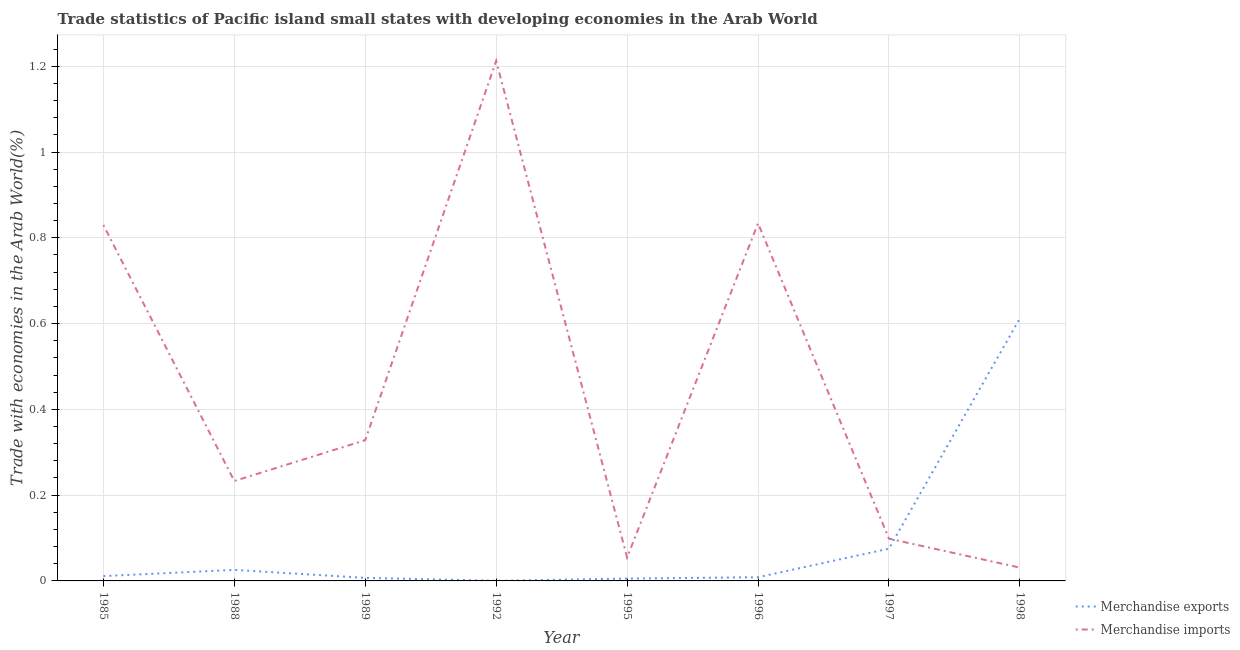What is the merchandise imports in 1992?
Keep it short and to the point. 1.21. Across all years, what is the maximum merchandise imports?
Make the answer very short. 1.21. Across all years, what is the minimum merchandise imports?
Your answer should be compact. 0.03. In which year was the merchandise imports minimum?
Provide a short and direct response. 1998. What is the total merchandise imports in the graph?
Provide a short and direct response. 3.62. What is the difference between the merchandise exports in 1989 and that in 1998?
Your response must be concise. -0.61. What is the difference between the merchandise exports in 1992 and the merchandise imports in 1995?
Offer a terse response. -0.05. What is the average merchandise exports per year?
Make the answer very short. 0.09. In the year 1995, what is the difference between the merchandise imports and merchandise exports?
Make the answer very short. 0.05. What is the ratio of the merchandise exports in 1995 to that in 1997?
Provide a short and direct response. 0.07. Is the difference between the merchandise imports in 1985 and 1996 greater than the difference between the merchandise exports in 1985 and 1996?
Your response must be concise. No. What is the difference between the highest and the second highest merchandise imports?
Your response must be concise. 0.38. What is the difference between the highest and the lowest merchandise exports?
Your answer should be compact. 0.61. Is the sum of the merchandise exports in 1985 and 1992 greater than the maximum merchandise imports across all years?
Keep it short and to the point. No. How many lines are there?
Your answer should be compact. 2. How many years are there in the graph?
Give a very brief answer. 8. Does the graph contain grids?
Provide a short and direct response. Yes. What is the title of the graph?
Your answer should be very brief. Trade statistics of Pacific island small states with developing economies in the Arab World. Does "All education staff compensation" appear as one of the legend labels in the graph?
Give a very brief answer. No. What is the label or title of the Y-axis?
Offer a terse response. Trade with economies in the Arab World(%). What is the Trade with economies in the Arab World(%) in Merchandise exports in 1985?
Keep it short and to the point. 0.01. What is the Trade with economies in the Arab World(%) of Merchandise imports in 1985?
Make the answer very short. 0.83. What is the Trade with economies in the Arab World(%) in Merchandise exports in 1988?
Make the answer very short. 0.03. What is the Trade with economies in the Arab World(%) of Merchandise imports in 1988?
Keep it short and to the point. 0.23. What is the Trade with economies in the Arab World(%) in Merchandise exports in 1989?
Keep it short and to the point. 0.01. What is the Trade with economies in the Arab World(%) in Merchandise imports in 1989?
Your answer should be compact. 0.33. What is the Trade with economies in the Arab World(%) in Merchandise exports in 1992?
Your response must be concise. 0. What is the Trade with economies in the Arab World(%) in Merchandise imports in 1992?
Your response must be concise. 1.21. What is the Trade with economies in the Arab World(%) of Merchandise exports in 1995?
Give a very brief answer. 0.01. What is the Trade with economies in the Arab World(%) in Merchandise imports in 1995?
Ensure brevity in your answer.  0.05. What is the Trade with economies in the Arab World(%) of Merchandise exports in 1996?
Your response must be concise. 0.01. What is the Trade with economies in the Arab World(%) in Merchandise imports in 1996?
Your answer should be compact. 0.83. What is the Trade with economies in the Arab World(%) of Merchandise exports in 1997?
Provide a succinct answer. 0.08. What is the Trade with economies in the Arab World(%) in Merchandise imports in 1997?
Ensure brevity in your answer.  0.1. What is the Trade with economies in the Arab World(%) of Merchandise exports in 1998?
Offer a terse response. 0.61. What is the Trade with economies in the Arab World(%) in Merchandise imports in 1998?
Offer a terse response. 0.03. Across all years, what is the maximum Trade with economies in the Arab World(%) in Merchandise exports?
Make the answer very short. 0.61. Across all years, what is the maximum Trade with economies in the Arab World(%) of Merchandise imports?
Make the answer very short. 1.21. Across all years, what is the minimum Trade with economies in the Arab World(%) in Merchandise exports?
Give a very brief answer. 0. Across all years, what is the minimum Trade with economies in the Arab World(%) of Merchandise imports?
Provide a succinct answer. 0.03. What is the total Trade with economies in the Arab World(%) in Merchandise exports in the graph?
Give a very brief answer. 0.75. What is the total Trade with economies in the Arab World(%) in Merchandise imports in the graph?
Keep it short and to the point. 3.62. What is the difference between the Trade with economies in the Arab World(%) in Merchandise exports in 1985 and that in 1988?
Provide a short and direct response. -0.01. What is the difference between the Trade with economies in the Arab World(%) of Merchandise imports in 1985 and that in 1988?
Provide a succinct answer. 0.6. What is the difference between the Trade with economies in the Arab World(%) in Merchandise exports in 1985 and that in 1989?
Provide a short and direct response. 0. What is the difference between the Trade with economies in the Arab World(%) in Merchandise imports in 1985 and that in 1989?
Your response must be concise. 0.5. What is the difference between the Trade with economies in the Arab World(%) in Merchandise exports in 1985 and that in 1992?
Your answer should be very brief. 0.01. What is the difference between the Trade with economies in the Arab World(%) of Merchandise imports in 1985 and that in 1992?
Keep it short and to the point. -0.38. What is the difference between the Trade with economies in the Arab World(%) in Merchandise exports in 1985 and that in 1995?
Your answer should be compact. 0.01. What is the difference between the Trade with economies in the Arab World(%) of Merchandise imports in 1985 and that in 1995?
Ensure brevity in your answer.  0.78. What is the difference between the Trade with economies in the Arab World(%) of Merchandise exports in 1985 and that in 1996?
Keep it short and to the point. 0. What is the difference between the Trade with economies in the Arab World(%) of Merchandise imports in 1985 and that in 1996?
Your response must be concise. -0. What is the difference between the Trade with economies in the Arab World(%) in Merchandise exports in 1985 and that in 1997?
Offer a very short reply. -0.06. What is the difference between the Trade with economies in the Arab World(%) in Merchandise imports in 1985 and that in 1997?
Ensure brevity in your answer.  0.73. What is the difference between the Trade with economies in the Arab World(%) of Merchandise exports in 1985 and that in 1998?
Offer a very short reply. -0.6. What is the difference between the Trade with economies in the Arab World(%) of Merchandise imports in 1985 and that in 1998?
Offer a very short reply. 0.8. What is the difference between the Trade with economies in the Arab World(%) in Merchandise exports in 1988 and that in 1989?
Ensure brevity in your answer.  0.02. What is the difference between the Trade with economies in the Arab World(%) in Merchandise imports in 1988 and that in 1989?
Provide a succinct answer. -0.1. What is the difference between the Trade with economies in the Arab World(%) of Merchandise exports in 1988 and that in 1992?
Your answer should be very brief. 0.03. What is the difference between the Trade with economies in the Arab World(%) of Merchandise imports in 1988 and that in 1992?
Your answer should be compact. -0.98. What is the difference between the Trade with economies in the Arab World(%) of Merchandise exports in 1988 and that in 1995?
Make the answer very short. 0.02. What is the difference between the Trade with economies in the Arab World(%) in Merchandise imports in 1988 and that in 1995?
Give a very brief answer. 0.18. What is the difference between the Trade with economies in the Arab World(%) in Merchandise exports in 1988 and that in 1996?
Your answer should be compact. 0.02. What is the difference between the Trade with economies in the Arab World(%) in Merchandise imports in 1988 and that in 1996?
Provide a short and direct response. -0.6. What is the difference between the Trade with economies in the Arab World(%) in Merchandise exports in 1988 and that in 1997?
Give a very brief answer. -0.05. What is the difference between the Trade with economies in the Arab World(%) in Merchandise imports in 1988 and that in 1997?
Provide a short and direct response. 0.13. What is the difference between the Trade with economies in the Arab World(%) of Merchandise exports in 1988 and that in 1998?
Your answer should be very brief. -0.59. What is the difference between the Trade with economies in the Arab World(%) in Merchandise imports in 1988 and that in 1998?
Give a very brief answer. 0.2. What is the difference between the Trade with economies in the Arab World(%) in Merchandise exports in 1989 and that in 1992?
Offer a very short reply. 0.01. What is the difference between the Trade with economies in the Arab World(%) of Merchandise imports in 1989 and that in 1992?
Give a very brief answer. -0.88. What is the difference between the Trade with economies in the Arab World(%) in Merchandise exports in 1989 and that in 1995?
Make the answer very short. 0. What is the difference between the Trade with economies in the Arab World(%) in Merchandise imports in 1989 and that in 1995?
Make the answer very short. 0.27. What is the difference between the Trade with economies in the Arab World(%) in Merchandise exports in 1989 and that in 1996?
Your answer should be compact. -0. What is the difference between the Trade with economies in the Arab World(%) in Merchandise imports in 1989 and that in 1996?
Provide a short and direct response. -0.51. What is the difference between the Trade with economies in the Arab World(%) of Merchandise exports in 1989 and that in 1997?
Provide a succinct answer. -0.07. What is the difference between the Trade with economies in the Arab World(%) of Merchandise imports in 1989 and that in 1997?
Provide a succinct answer. 0.23. What is the difference between the Trade with economies in the Arab World(%) of Merchandise exports in 1989 and that in 1998?
Offer a terse response. -0.61. What is the difference between the Trade with economies in the Arab World(%) in Merchandise imports in 1989 and that in 1998?
Your answer should be very brief. 0.3. What is the difference between the Trade with economies in the Arab World(%) of Merchandise exports in 1992 and that in 1995?
Your response must be concise. -0.01. What is the difference between the Trade with economies in the Arab World(%) in Merchandise imports in 1992 and that in 1995?
Keep it short and to the point. 1.16. What is the difference between the Trade with economies in the Arab World(%) of Merchandise exports in 1992 and that in 1996?
Ensure brevity in your answer.  -0.01. What is the difference between the Trade with economies in the Arab World(%) of Merchandise imports in 1992 and that in 1996?
Give a very brief answer. 0.38. What is the difference between the Trade with economies in the Arab World(%) of Merchandise exports in 1992 and that in 1997?
Provide a short and direct response. -0.07. What is the difference between the Trade with economies in the Arab World(%) of Merchandise imports in 1992 and that in 1997?
Make the answer very short. 1.11. What is the difference between the Trade with economies in the Arab World(%) in Merchandise exports in 1992 and that in 1998?
Make the answer very short. -0.61. What is the difference between the Trade with economies in the Arab World(%) in Merchandise imports in 1992 and that in 1998?
Provide a succinct answer. 1.18. What is the difference between the Trade with economies in the Arab World(%) of Merchandise exports in 1995 and that in 1996?
Your answer should be very brief. -0. What is the difference between the Trade with economies in the Arab World(%) in Merchandise imports in 1995 and that in 1996?
Offer a very short reply. -0.78. What is the difference between the Trade with economies in the Arab World(%) in Merchandise exports in 1995 and that in 1997?
Provide a short and direct response. -0.07. What is the difference between the Trade with economies in the Arab World(%) in Merchandise imports in 1995 and that in 1997?
Provide a succinct answer. -0.04. What is the difference between the Trade with economies in the Arab World(%) in Merchandise exports in 1995 and that in 1998?
Provide a short and direct response. -0.61. What is the difference between the Trade with economies in the Arab World(%) of Merchandise imports in 1995 and that in 1998?
Provide a succinct answer. 0.02. What is the difference between the Trade with economies in the Arab World(%) in Merchandise exports in 1996 and that in 1997?
Provide a short and direct response. -0.07. What is the difference between the Trade with economies in the Arab World(%) of Merchandise imports in 1996 and that in 1997?
Your answer should be compact. 0.74. What is the difference between the Trade with economies in the Arab World(%) of Merchandise exports in 1996 and that in 1998?
Give a very brief answer. -0.6. What is the difference between the Trade with economies in the Arab World(%) of Merchandise imports in 1996 and that in 1998?
Offer a terse response. 0.8. What is the difference between the Trade with economies in the Arab World(%) in Merchandise exports in 1997 and that in 1998?
Make the answer very short. -0.54. What is the difference between the Trade with economies in the Arab World(%) of Merchandise imports in 1997 and that in 1998?
Ensure brevity in your answer.  0.07. What is the difference between the Trade with economies in the Arab World(%) of Merchandise exports in 1985 and the Trade with economies in the Arab World(%) of Merchandise imports in 1988?
Your answer should be very brief. -0.22. What is the difference between the Trade with economies in the Arab World(%) of Merchandise exports in 1985 and the Trade with economies in the Arab World(%) of Merchandise imports in 1989?
Your answer should be very brief. -0.32. What is the difference between the Trade with economies in the Arab World(%) in Merchandise exports in 1985 and the Trade with economies in the Arab World(%) in Merchandise imports in 1992?
Offer a very short reply. -1.2. What is the difference between the Trade with economies in the Arab World(%) of Merchandise exports in 1985 and the Trade with economies in the Arab World(%) of Merchandise imports in 1995?
Make the answer very short. -0.04. What is the difference between the Trade with economies in the Arab World(%) of Merchandise exports in 1985 and the Trade with economies in the Arab World(%) of Merchandise imports in 1996?
Make the answer very short. -0.82. What is the difference between the Trade with economies in the Arab World(%) of Merchandise exports in 1985 and the Trade with economies in the Arab World(%) of Merchandise imports in 1997?
Give a very brief answer. -0.09. What is the difference between the Trade with economies in the Arab World(%) in Merchandise exports in 1985 and the Trade with economies in the Arab World(%) in Merchandise imports in 1998?
Make the answer very short. -0.02. What is the difference between the Trade with economies in the Arab World(%) in Merchandise exports in 1988 and the Trade with economies in the Arab World(%) in Merchandise imports in 1989?
Give a very brief answer. -0.3. What is the difference between the Trade with economies in the Arab World(%) of Merchandise exports in 1988 and the Trade with economies in the Arab World(%) of Merchandise imports in 1992?
Provide a succinct answer. -1.19. What is the difference between the Trade with economies in the Arab World(%) of Merchandise exports in 1988 and the Trade with economies in the Arab World(%) of Merchandise imports in 1995?
Keep it short and to the point. -0.03. What is the difference between the Trade with economies in the Arab World(%) in Merchandise exports in 1988 and the Trade with economies in the Arab World(%) in Merchandise imports in 1996?
Your answer should be very brief. -0.81. What is the difference between the Trade with economies in the Arab World(%) in Merchandise exports in 1988 and the Trade with economies in the Arab World(%) in Merchandise imports in 1997?
Offer a terse response. -0.07. What is the difference between the Trade with economies in the Arab World(%) of Merchandise exports in 1988 and the Trade with economies in the Arab World(%) of Merchandise imports in 1998?
Offer a terse response. -0.01. What is the difference between the Trade with economies in the Arab World(%) of Merchandise exports in 1989 and the Trade with economies in the Arab World(%) of Merchandise imports in 1992?
Give a very brief answer. -1.21. What is the difference between the Trade with economies in the Arab World(%) of Merchandise exports in 1989 and the Trade with economies in the Arab World(%) of Merchandise imports in 1995?
Provide a succinct answer. -0.05. What is the difference between the Trade with economies in the Arab World(%) in Merchandise exports in 1989 and the Trade with economies in the Arab World(%) in Merchandise imports in 1996?
Your answer should be very brief. -0.83. What is the difference between the Trade with economies in the Arab World(%) in Merchandise exports in 1989 and the Trade with economies in the Arab World(%) in Merchandise imports in 1997?
Provide a succinct answer. -0.09. What is the difference between the Trade with economies in the Arab World(%) in Merchandise exports in 1989 and the Trade with economies in the Arab World(%) in Merchandise imports in 1998?
Ensure brevity in your answer.  -0.02. What is the difference between the Trade with economies in the Arab World(%) of Merchandise exports in 1992 and the Trade with economies in the Arab World(%) of Merchandise imports in 1995?
Provide a short and direct response. -0.05. What is the difference between the Trade with economies in the Arab World(%) in Merchandise exports in 1992 and the Trade with economies in the Arab World(%) in Merchandise imports in 1996?
Provide a short and direct response. -0.83. What is the difference between the Trade with economies in the Arab World(%) of Merchandise exports in 1992 and the Trade with economies in the Arab World(%) of Merchandise imports in 1997?
Your answer should be compact. -0.1. What is the difference between the Trade with economies in the Arab World(%) of Merchandise exports in 1992 and the Trade with economies in the Arab World(%) of Merchandise imports in 1998?
Ensure brevity in your answer.  -0.03. What is the difference between the Trade with economies in the Arab World(%) in Merchandise exports in 1995 and the Trade with economies in the Arab World(%) in Merchandise imports in 1996?
Keep it short and to the point. -0.83. What is the difference between the Trade with economies in the Arab World(%) of Merchandise exports in 1995 and the Trade with economies in the Arab World(%) of Merchandise imports in 1997?
Your answer should be compact. -0.09. What is the difference between the Trade with economies in the Arab World(%) of Merchandise exports in 1995 and the Trade with economies in the Arab World(%) of Merchandise imports in 1998?
Give a very brief answer. -0.03. What is the difference between the Trade with economies in the Arab World(%) in Merchandise exports in 1996 and the Trade with economies in the Arab World(%) in Merchandise imports in 1997?
Your answer should be compact. -0.09. What is the difference between the Trade with economies in the Arab World(%) of Merchandise exports in 1996 and the Trade with economies in the Arab World(%) of Merchandise imports in 1998?
Ensure brevity in your answer.  -0.02. What is the difference between the Trade with economies in the Arab World(%) of Merchandise exports in 1997 and the Trade with economies in the Arab World(%) of Merchandise imports in 1998?
Offer a terse response. 0.04. What is the average Trade with economies in the Arab World(%) of Merchandise exports per year?
Give a very brief answer. 0.09. What is the average Trade with economies in the Arab World(%) of Merchandise imports per year?
Ensure brevity in your answer.  0.45. In the year 1985, what is the difference between the Trade with economies in the Arab World(%) in Merchandise exports and Trade with economies in the Arab World(%) in Merchandise imports?
Your answer should be very brief. -0.82. In the year 1988, what is the difference between the Trade with economies in the Arab World(%) in Merchandise exports and Trade with economies in the Arab World(%) in Merchandise imports?
Give a very brief answer. -0.21. In the year 1989, what is the difference between the Trade with economies in the Arab World(%) in Merchandise exports and Trade with economies in the Arab World(%) in Merchandise imports?
Your response must be concise. -0.32. In the year 1992, what is the difference between the Trade with economies in the Arab World(%) of Merchandise exports and Trade with economies in the Arab World(%) of Merchandise imports?
Your answer should be compact. -1.21. In the year 1995, what is the difference between the Trade with economies in the Arab World(%) in Merchandise exports and Trade with economies in the Arab World(%) in Merchandise imports?
Ensure brevity in your answer.  -0.05. In the year 1996, what is the difference between the Trade with economies in the Arab World(%) in Merchandise exports and Trade with economies in the Arab World(%) in Merchandise imports?
Give a very brief answer. -0.83. In the year 1997, what is the difference between the Trade with economies in the Arab World(%) of Merchandise exports and Trade with economies in the Arab World(%) of Merchandise imports?
Make the answer very short. -0.02. In the year 1998, what is the difference between the Trade with economies in the Arab World(%) in Merchandise exports and Trade with economies in the Arab World(%) in Merchandise imports?
Keep it short and to the point. 0.58. What is the ratio of the Trade with economies in the Arab World(%) in Merchandise exports in 1985 to that in 1988?
Your answer should be compact. 0.44. What is the ratio of the Trade with economies in the Arab World(%) of Merchandise imports in 1985 to that in 1988?
Your answer should be very brief. 3.56. What is the ratio of the Trade with economies in the Arab World(%) of Merchandise exports in 1985 to that in 1989?
Offer a very short reply. 1.57. What is the ratio of the Trade with economies in the Arab World(%) of Merchandise imports in 1985 to that in 1989?
Ensure brevity in your answer.  2.53. What is the ratio of the Trade with economies in the Arab World(%) of Merchandise exports in 1985 to that in 1992?
Give a very brief answer. 34.52. What is the ratio of the Trade with economies in the Arab World(%) in Merchandise imports in 1985 to that in 1992?
Your answer should be very brief. 0.68. What is the ratio of the Trade with economies in the Arab World(%) in Merchandise exports in 1985 to that in 1995?
Make the answer very short. 2.06. What is the ratio of the Trade with economies in the Arab World(%) in Merchandise imports in 1985 to that in 1995?
Your answer should be compact. 15.21. What is the ratio of the Trade with economies in the Arab World(%) in Merchandise exports in 1985 to that in 1996?
Give a very brief answer. 1.3. What is the ratio of the Trade with economies in the Arab World(%) in Merchandise imports in 1985 to that in 1996?
Your answer should be very brief. 1. What is the ratio of the Trade with economies in the Arab World(%) in Merchandise exports in 1985 to that in 1997?
Keep it short and to the point. 0.15. What is the ratio of the Trade with economies in the Arab World(%) in Merchandise imports in 1985 to that in 1997?
Provide a short and direct response. 8.42. What is the ratio of the Trade with economies in the Arab World(%) in Merchandise exports in 1985 to that in 1998?
Give a very brief answer. 0.02. What is the ratio of the Trade with economies in the Arab World(%) in Merchandise imports in 1985 to that in 1998?
Make the answer very short. 26.81. What is the ratio of the Trade with economies in the Arab World(%) of Merchandise exports in 1988 to that in 1989?
Offer a very short reply. 3.6. What is the ratio of the Trade with economies in the Arab World(%) in Merchandise imports in 1988 to that in 1989?
Offer a terse response. 0.71. What is the ratio of the Trade with economies in the Arab World(%) in Merchandise exports in 1988 to that in 1992?
Provide a succinct answer. 79.11. What is the ratio of the Trade with economies in the Arab World(%) in Merchandise imports in 1988 to that in 1992?
Provide a short and direct response. 0.19. What is the ratio of the Trade with economies in the Arab World(%) in Merchandise exports in 1988 to that in 1995?
Provide a short and direct response. 4.73. What is the ratio of the Trade with economies in the Arab World(%) in Merchandise imports in 1988 to that in 1995?
Provide a succinct answer. 4.27. What is the ratio of the Trade with economies in the Arab World(%) of Merchandise exports in 1988 to that in 1996?
Your answer should be compact. 2.98. What is the ratio of the Trade with economies in the Arab World(%) of Merchandise imports in 1988 to that in 1996?
Provide a short and direct response. 0.28. What is the ratio of the Trade with economies in the Arab World(%) of Merchandise exports in 1988 to that in 1997?
Provide a succinct answer. 0.34. What is the ratio of the Trade with economies in the Arab World(%) of Merchandise imports in 1988 to that in 1997?
Your answer should be very brief. 2.37. What is the ratio of the Trade with economies in the Arab World(%) in Merchandise exports in 1988 to that in 1998?
Your response must be concise. 0.04. What is the ratio of the Trade with economies in the Arab World(%) of Merchandise imports in 1988 to that in 1998?
Make the answer very short. 7.53. What is the ratio of the Trade with economies in the Arab World(%) in Merchandise exports in 1989 to that in 1992?
Ensure brevity in your answer.  22. What is the ratio of the Trade with economies in the Arab World(%) of Merchandise imports in 1989 to that in 1992?
Provide a succinct answer. 0.27. What is the ratio of the Trade with economies in the Arab World(%) of Merchandise exports in 1989 to that in 1995?
Your answer should be very brief. 1.32. What is the ratio of the Trade with economies in the Arab World(%) in Merchandise imports in 1989 to that in 1995?
Your answer should be very brief. 6.02. What is the ratio of the Trade with economies in the Arab World(%) of Merchandise exports in 1989 to that in 1996?
Make the answer very short. 0.83. What is the ratio of the Trade with economies in the Arab World(%) of Merchandise imports in 1989 to that in 1996?
Your answer should be very brief. 0.39. What is the ratio of the Trade with economies in the Arab World(%) of Merchandise exports in 1989 to that in 1997?
Provide a succinct answer. 0.1. What is the ratio of the Trade with economies in the Arab World(%) in Merchandise imports in 1989 to that in 1997?
Give a very brief answer. 3.33. What is the ratio of the Trade with economies in the Arab World(%) in Merchandise exports in 1989 to that in 1998?
Give a very brief answer. 0.01. What is the ratio of the Trade with economies in the Arab World(%) in Merchandise imports in 1989 to that in 1998?
Offer a terse response. 10.6. What is the ratio of the Trade with economies in the Arab World(%) in Merchandise exports in 1992 to that in 1995?
Provide a succinct answer. 0.06. What is the ratio of the Trade with economies in the Arab World(%) of Merchandise imports in 1992 to that in 1995?
Provide a short and direct response. 22.23. What is the ratio of the Trade with economies in the Arab World(%) of Merchandise exports in 1992 to that in 1996?
Your answer should be very brief. 0.04. What is the ratio of the Trade with economies in the Arab World(%) of Merchandise imports in 1992 to that in 1996?
Provide a succinct answer. 1.45. What is the ratio of the Trade with economies in the Arab World(%) of Merchandise exports in 1992 to that in 1997?
Give a very brief answer. 0. What is the ratio of the Trade with economies in the Arab World(%) of Merchandise imports in 1992 to that in 1997?
Offer a very short reply. 12.31. What is the ratio of the Trade with economies in the Arab World(%) of Merchandise exports in 1992 to that in 1998?
Keep it short and to the point. 0. What is the ratio of the Trade with economies in the Arab World(%) in Merchandise imports in 1992 to that in 1998?
Offer a terse response. 39.17. What is the ratio of the Trade with economies in the Arab World(%) of Merchandise exports in 1995 to that in 1996?
Offer a terse response. 0.63. What is the ratio of the Trade with economies in the Arab World(%) of Merchandise imports in 1995 to that in 1996?
Offer a very short reply. 0.07. What is the ratio of the Trade with economies in the Arab World(%) of Merchandise exports in 1995 to that in 1997?
Offer a terse response. 0.07. What is the ratio of the Trade with economies in the Arab World(%) in Merchandise imports in 1995 to that in 1997?
Offer a very short reply. 0.55. What is the ratio of the Trade with economies in the Arab World(%) of Merchandise exports in 1995 to that in 1998?
Make the answer very short. 0.01. What is the ratio of the Trade with economies in the Arab World(%) in Merchandise imports in 1995 to that in 1998?
Keep it short and to the point. 1.76. What is the ratio of the Trade with economies in the Arab World(%) of Merchandise exports in 1996 to that in 1997?
Your response must be concise. 0.11. What is the ratio of the Trade with economies in the Arab World(%) in Merchandise imports in 1996 to that in 1997?
Provide a succinct answer. 8.46. What is the ratio of the Trade with economies in the Arab World(%) of Merchandise exports in 1996 to that in 1998?
Your response must be concise. 0.01. What is the ratio of the Trade with economies in the Arab World(%) in Merchandise imports in 1996 to that in 1998?
Make the answer very short. 26.93. What is the ratio of the Trade with economies in the Arab World(%) of Merchandise exports in 1997 to that in 1998?
Provide a short and direct response. 0.12. What is the ratio of the Trade with economies in the Arab World(%) of Merchandise imports in 1997 to that in 1998?
Provide a succinct answer. 3.18. What is the difference between the highest and the second highest Trade with economies in the Arab World(%) in Merchandise exports?
Offer a terse response. 0.54. What is the difference between the highest and the second highest Trade with economies in the Arab World(%) in Merchandise imports?
Your response must be concise. 0.38. What is the difference between the highest and the lowest Trade with economies in the Arab World(%) of Merchandise exports?
Offer a very short reply. 0.61. What is the difference between the highest and the lowest Trade with economies in the Arab World(%) in Merchandise imports?
Offer a very short reply. 1.18. 